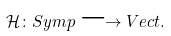<formula> <loc_0><loc_0><loc_500><loc_500>\mathcal { H } \colon S y m p \longrightarrow V e c t .</formula> 